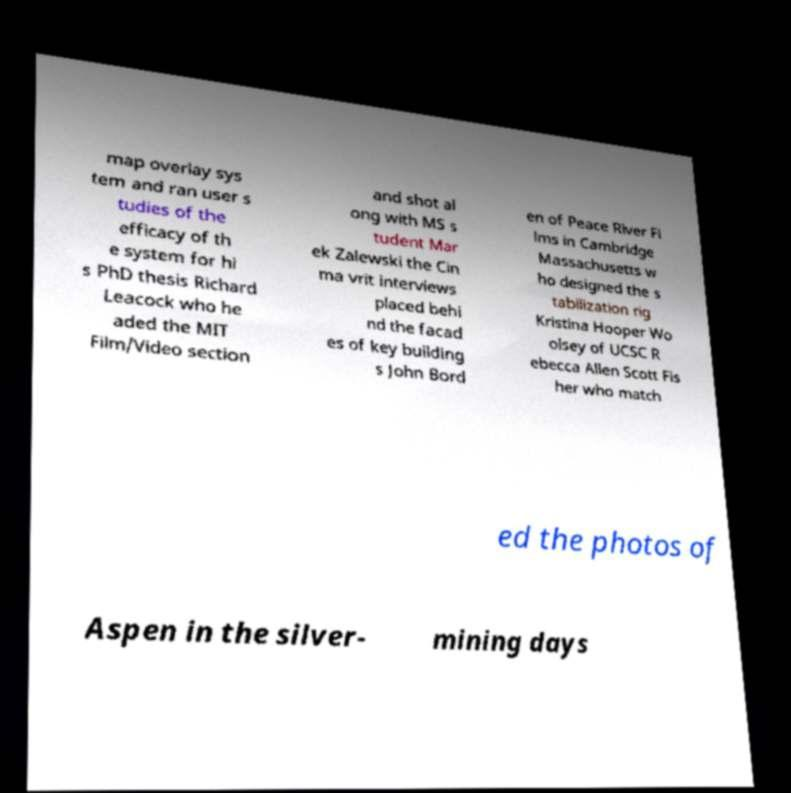I need the written content from this picture converted into text. Can you do that? map overlay sys tem and ran user s tudies of the efficacy of th e system for hi s PhD thesis Richard Leacock who he aded the MIT Film/Video section and shot al ong with MS s tudent Mar ek Zalewski the Cin ma vrit interviews placed behi nd the facad es of key building s John Bord en of Peace River Fi lms in Cambridge Massachusetts w ho designed the s tabilization rig Kristina Hooper Wo olsey of UCSC R ebecca Allen Scott Fis her who match ed the photos of Aspen in the silver- mining days 